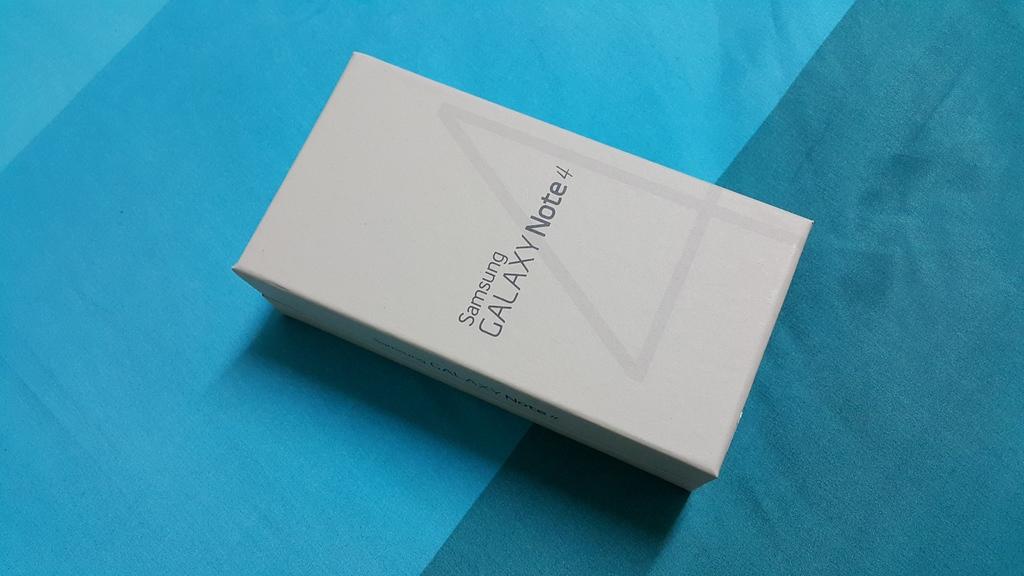What brand is this box?
Offer a terse response. Samsung. What type of phone is in this box?
Keep it short and to the point. Samsung galaxy note 4. 